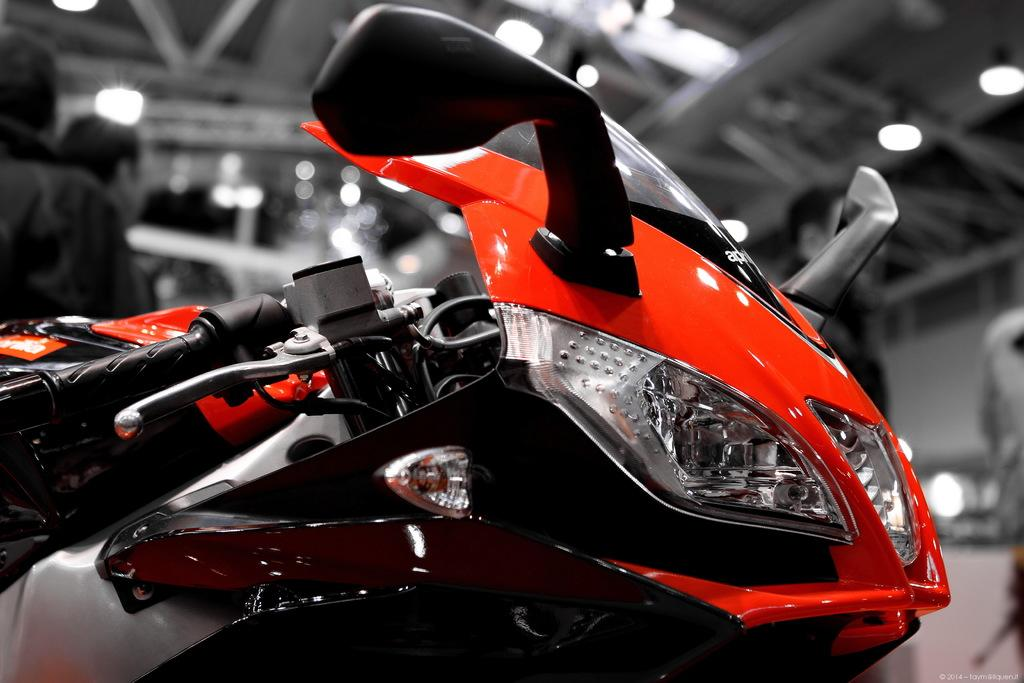What is the main subject of the image? The main subject of the image is a motorbike. What can be seen on the roof in the image? There are metal poles and lights on the roof in the image. Are there any people visible in the image? Yes, there are people visible in the image. What type of haircut does the throne have in the image? There is no throne present in the image, so it is not possible to answer that question. 